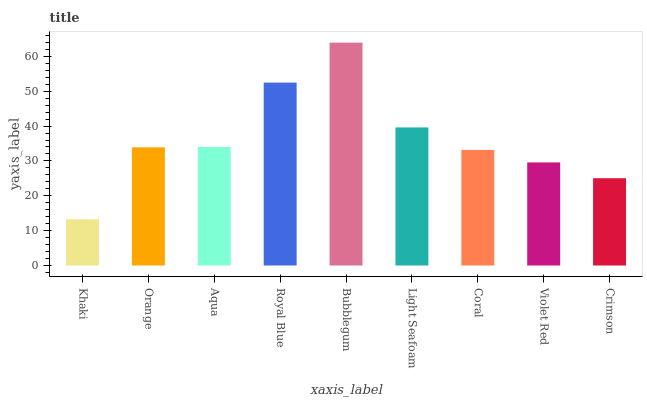Is Khaki the minimum?
Answer yes or no. Yes. Is Bubblegum the maximum?
Answer yes or no. Yes. Is Orange the minimum?
Answer yes or no. No. Is Orange the maximum?
Answer yes or no. No. Is Orange greater than Khaki?
Answer yes or no. Yes. Is Khaki less than Orange?
Answer yes or no. Yes. Is Khaki greater than Orange?
Answer yes or no. No. Is Orange less than Khaki?
Answer yes or no. No. Is Orange the high median?
Answer yes or no. Yes. Is Orange the low median?
Answer yes or no. Yes. Is Aqua the high median?
Answer yes or no. No. Is Crimson the low median?
Answer yes or no. No. 